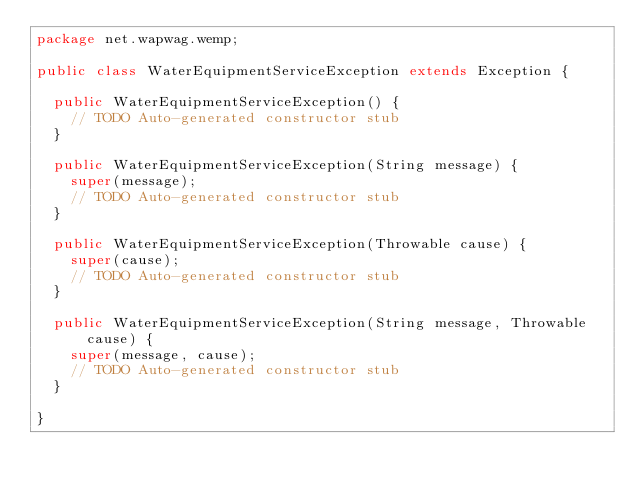Convert code to text. <code><loc_0><loc_0><loc_500><loc_500><_Java_>package net.wapwag.wemp;

public class WaterEquipmentServiceException extends Exception {

	public WaterEquipmentServiceException() {
		// TODO Auto-generated constructor stub
	}

	public WaterEquipmentServiceException(String message) {
		super(message);
		// TODO Auto-generated constructor stub
	}

	public WaterEquipmentServiceException(Throwable cause) {
		super(cause);
		// TODO Auto-generated constructor stub
	}

	public WaterEquipmentServiceException(String message, Throwable cause) {
		super(message, cause);
		// TODO Auto-generated constructor stub
	}

}
</code> 